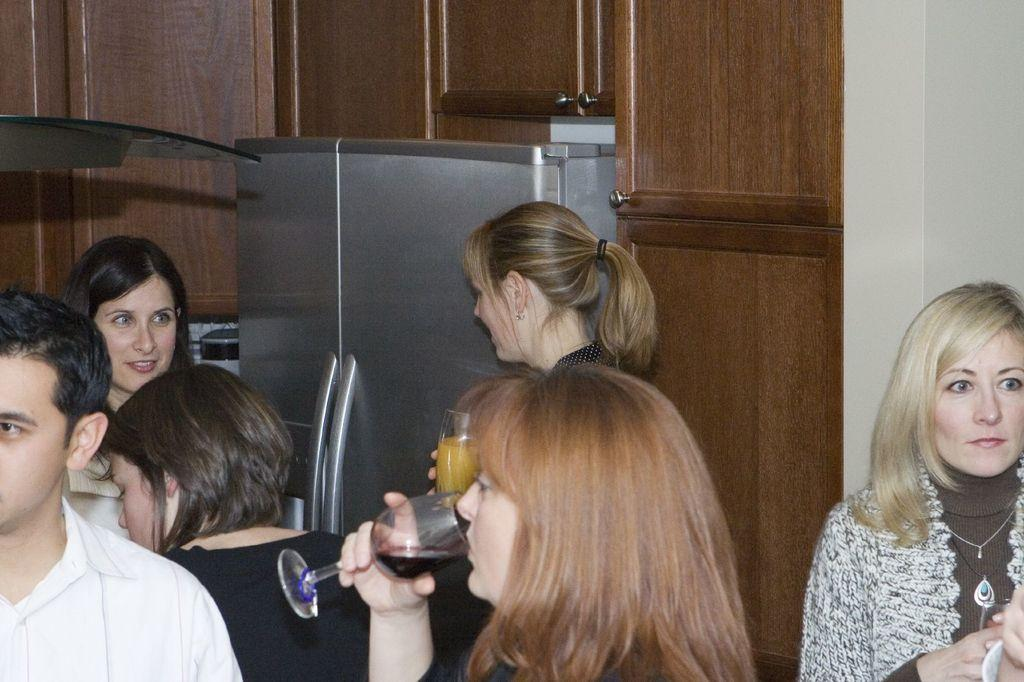What is the main subject of the image? The main subject of the image is a group of people. Can you describe the woman in the image? The woman is in the center of the group, and she is drinking wine. What can be seen in the background of the image? There is a cupboard in the background of the image. What type of wrench is the woman using to open the wine bottle in the image? There is no wrench present in the image, and the woman is not opening a wine bottle. 